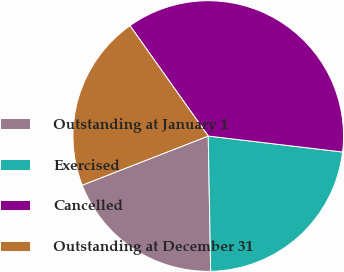Convert chart to OTSL. <chart><loc_0><loc_0><loc_500><loc_500><pie_chart><fcel>Outstanding at January 1<fcel>Exercised<fcel>Cancelled<fcel>Outstanding at December 31<nl><fcel>19.37%<fcel>22.83%<fcel>36.7%<fcel>21.1%<nl></chart> 